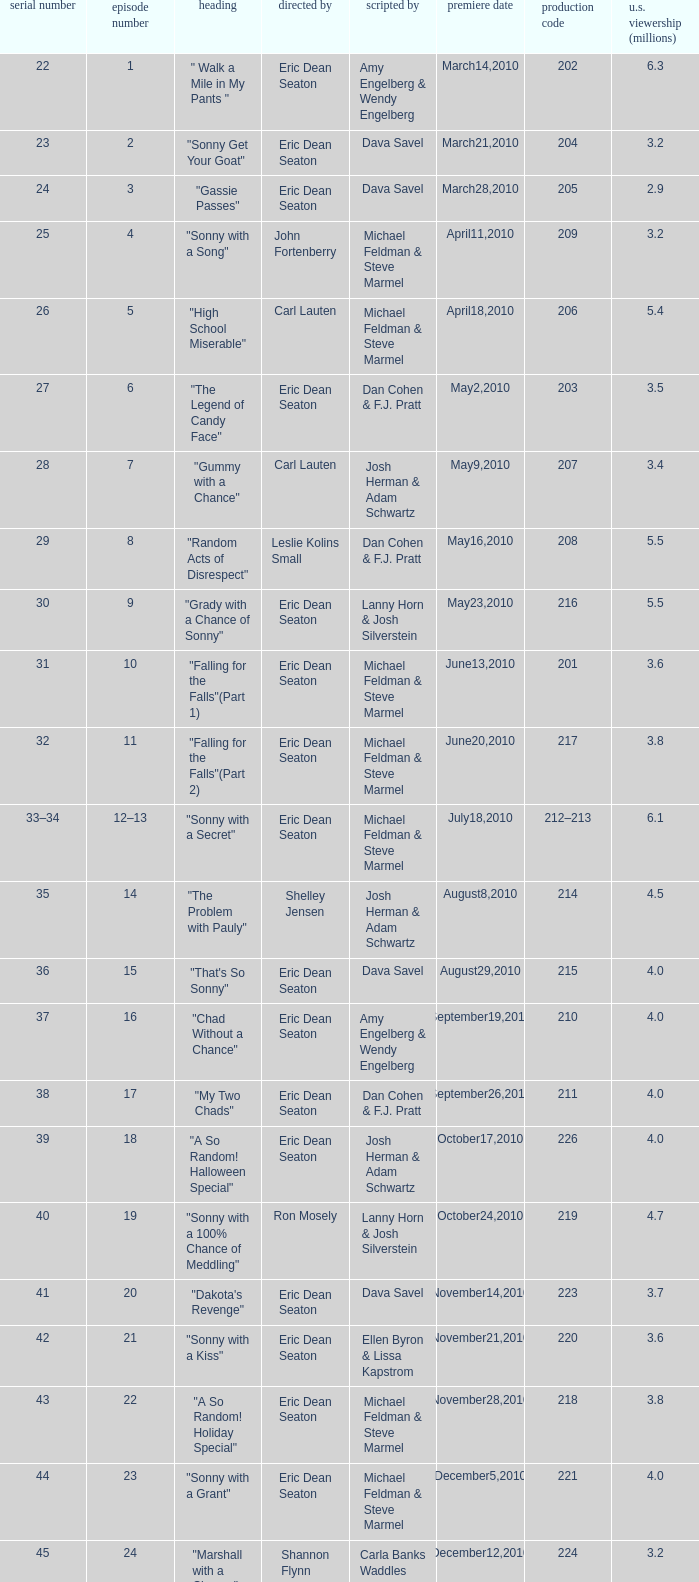How man episodes in the season were titled "that's so sonny"? 1.0. 